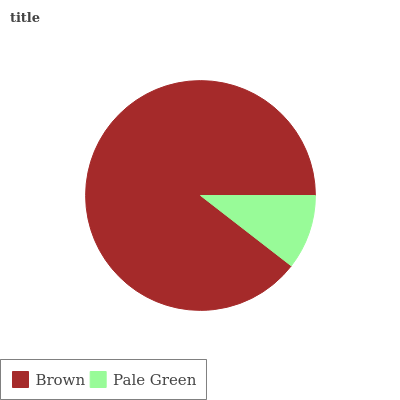Is Pale Green the minimum?
Answer yes or no. Yes. Is Brown the maximum?
Answer yes or no. Yes. Is Pale Green the maximum?
Answer yes or no. No. Is Brown greater than Pale Green?
Answer yes or no. Yes. Is Pale Green less than Brown?
Answer yes or no. Yes. Is Pale Green greater than Brown?
Answer yes or no. No. Is Brown less than Pale Green?
Answer yes or no. No. Is Brown the high median?
Answer yes or no. Yes. Is Pale Green the low median?
Answer yes or no. Yes. Is Pale Green the high median?
Answer yes or no. No. Is Brown the low median?
Answer yes or no. No. 